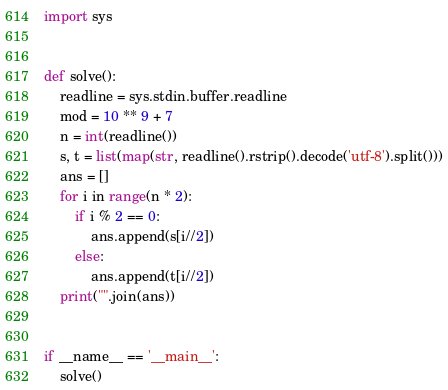Convert code to text. <code><loc_0><loc_0><loc_500><loc_500><_Python_>import sys


def solve():
    readline = sys.stdin.buffer.readline
    mod = 10 ** 9 + 7
    n = int(readline())
    s, t = list(map(str, readline().rstrip().decode('utf-8').split()))
    ans = []
    for i in range(n * 2):
        if i % 2 == 0:
            ans.append(s[i//2])
        else:
            ans.append(t[i//2])
    print("".join(ans))


if __name__ == '__main__':
    solve()
</code> 